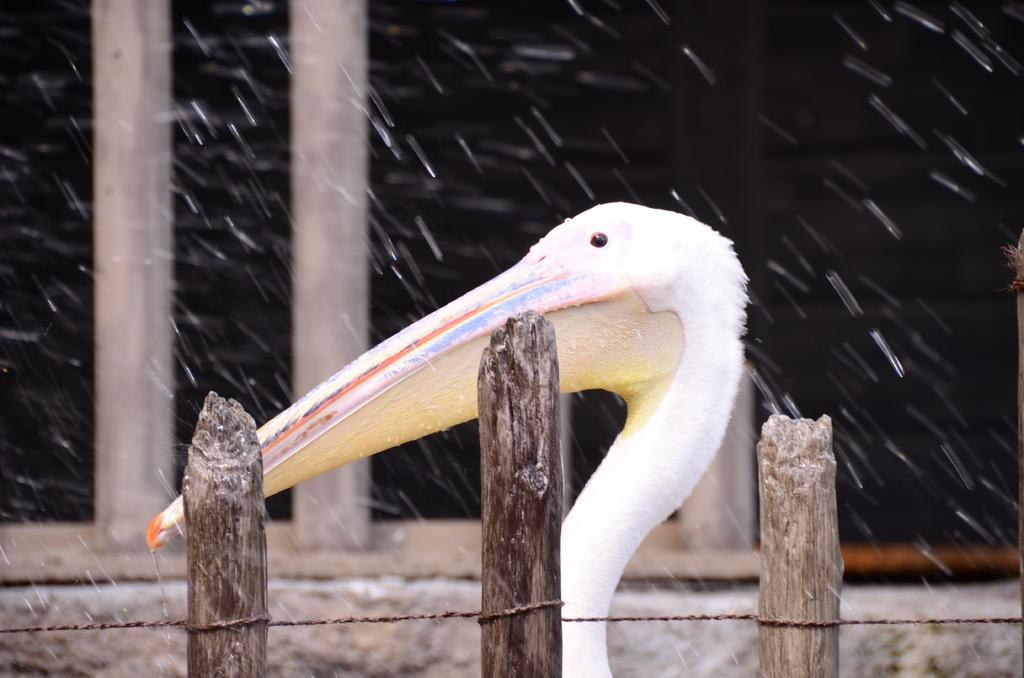Describe this image in one or two sentences. In this picture there is a bird behind the railing which is in white color. At the back there are poles and there are water droplets in the air. 